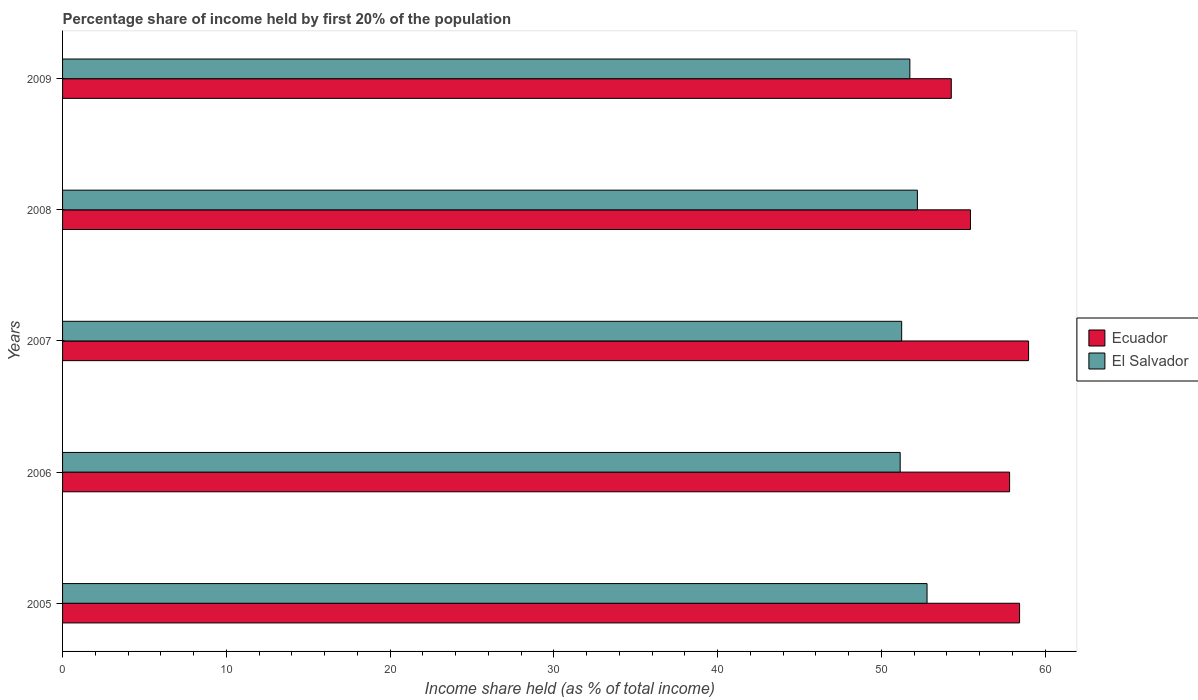How many different coloured bars are there?
Offer a terse response. 2. How many groups of bars are there?
Your response must be concise. 5. Are the number of bars per tick equal to the number of legend labels?
Your answer should be compact. Yes. How many bars are there on the 5th tick from the bottom?
Make the answer very short. 2. In how many cases, is the number of bars for a given year not equal to the number of legend labels?
Your response must be concise. 0. What is the share of income held by first 20% of the population in El Salvador in 2006?
Provide a succinct answer. 51.15. Across all years, what is the maximum share of income held by first 20% of the population in El Salvador?
Make the answer very short. 52.79. Across all years, what is the minimum share of income held by first 20% of the population in Ecuador?
Your answer should be compact. 54.27. In which year was the share of income held by first 20% of the population in Ecuador maximum?
Offer a terse response. 2007. In which year was the share of income held by first 20% of the population in El Salvador minimum?
Your response must be concise. 2006. What is the total share of income held by first 20% of the population in El Salvador in the graph?
Make the answer very short. 259.12. What is the difference between the share of income held by first 20% of the population in Ecuador in 2005 and that in 2006?
Ensure brevity in your answer.  0.61. What is the difference between the share of income held by first 20% of the population in El Salvador in 2005 and the share of income held by first 20% of the population in Ecuador in 2009?
Give a very brief answer. -1.48. What is the average share of income held by first 20% of the population in Ecuador per year?
Keep it short and to the point. 56.99. In the year 2008, what is the difference between the share of income held by first 20% of the population in El Salvador and share of income held by first 20% of the population in Ecuador?
Provide a short and direct response. -3.24. What is the ratio of the share of income held by first 20% of the population in El Salvador in 2005 to that in 2008?
Offer a terse response. 1.01. Is the share of income held by first 20% of the population in Ecuador in 2006 less than that in 2009?
Offer a terse response. No. What is the difference between the highest and the second highest share of income held by first 20% of the population in Ecuador?
Your answer should be very brief. 0.55. What is the difference between the highest and the lowest share of income held by first 20% of the population in Ecuador?
Provide a succinct answer. 4.72. What does the 2nd bar from the top in 2009 represents?
Your answer should be very brief. Ecuador. What does the 2nd bar from the bottom in 2006 represents?
Keep it short and to the point. El Salvador. How many bars are there?
Provide a short and direct response. 10. How many years are there in the graph?
Give a very brief answer. 5. Are the values on the major ticks of X-axis written in scientific E-notation?
Offer a terse response. No. Does the graph contain any zero values?
Offer a terse response. No. Does the graph contain grids?
Give a very brief answer. No. What is the title of the graph?
Provide a succinct answer. Percentage share of income held by first 20% of the population. Does "Russian Federation" appear as one of the legend labels in the graph?
Your answer should be compact. No. What is the label or title of the X-axis?
Provide a succinct answer. Income share held (as % of total income). What is the Income share held (as % of total income) in Ecuador in 2005?
Your answer should be very brief. 58.44. What is the Income share held (as % of total income) of El Salvador in 2005?
Give a very brief answer. 52.79. What is the Income share held (as % of total income) of Ecuador in 2006?
Give a very brief answer. 57.83. What is the Income share held (as % of total income) in El Salvador in 2006?
Make the answer very short. 51.15. What is the Income share held (as % of total income) of Ecuador in 2007?
Make the answer very short. 58.99. What is the Income share held (as % of total income) of El Salvador in 2007?
Your answer should be very brief. 51.24. What is the Income share held (as % of total income) of Ecuador in 2008?
Give a very brief answer. 55.44. What is the Income share held (as % of total income) of El Salvador in 2008?
Ensure brevity in your answer.  52.2. What is the Income share held (as % of total income) of Ecuador in 2009?
Offer a very short reply. 54.27. What is the Income share held (as % of total income) in El Salvador in 2009?
Offer a terse response. 51.74. Across all years, what is the maximum Income share held (as % of total income) of Ecuador?
Provide a short and direct response. 58.99. Across all years, what is the maximum Income share held (as % of total income) in El Salvador?
Your response must be concise. 52.79. Across all years, what is the minimum Income share held (as % of total income) of Ecuador?
Keep it short and to the point. 54.27. Across all years, what is the minimum Income share held (as % of total income) of El Salvador?
Your answer should be very brief. 51.15. What is the total Income share held (as % of total income) in Ecuador in the graph?
Offer a terse response. 284.97. What is the total Income share held (as % of total income) in El Salvador in the graph?
Offer a terse response. 259.12. What is the difference between the Income share held (as % of total income) in Ecuador in 2005 and that in 2006?
Provide a succinct answer. 0.61. What is the difference between the Income share held (as % of total income) of El Salvador in 2005 and that in 2006?
Your answer should be compact. 1.64. What is the difference between the Income share held (as % of total income) in Ecuador in 2005 and that in 2007?
Ensure brevity in your answer.  -0.55. What is the difference between the Income share held (as % of total income) in El Salvador in 2005 and that in 2007?
Make the answer very short. 1.55. What is the difference between the Income share held (as % of total income) in El Salvador in 2005 and that in 2008?
Offer a terse response. 0.59. What is the difference between the Income share held (as % of total income) of Ecuador in 2005 and that in 2009?
Make the answer very short. 4.17. What is the difference between the Income share held (as % of total income) in Ecuador in 2006 and that in 2007?
Your response must be concise. -1.16. What is the difference between the Income share held (as % of total income) of El Salvador in 2006 and that in 2007?
Your answer should be compact. -0.09. What is the difference between the Income share held (as % of total income) of Ecuador in 2006 and that in 2008?
Your answer should be very brief. 2.39. What is the difference between the Income share held (as % of total income) in El Salvador in 2006 and that in 2008?
Provide a succinct answer. -1.05. What is the difference between the Income share held (as % of total income) in Ecuador in 2006 and that in 2009?
Offer a very short reply. 3.56. What is the difference between the Income share held (as % of total income) of El Salvador in 2006 and that in 2009?
Keep it short and to the point. -0.59. What is the difference between the Income share held (as % of total income) of Ecuador in 2007 and that in 2008?
Your answer should be very brief. 3.55. What is the difference between the Income share held (as % of total income) of El Salvador in 2007 and that in 2008?
Provide a short and direct response. -0.96. What is the difference between the Income share held (as % of total income) in Ecuador in 2007 and that in 2009?
Make the answer very short. 4.72. What is the difference between the Income share held (as % of total income) in El Salvador in 2007 and that in 2009?
Keep it short and to the point. -0.5. What is the difference between the Income share held (as % of total income) of Ecuador in 2008 and that in 2009?
Keep it short and to the point. 1.17. What is the difference between the Income share held (as % of total income) of El Salvador in 2008 and that in 2009?
Your answer should be very brief. 0.46. What is the difference between the Income share held (as % of total income) of Ecuador in 2005 and the Income share held (as % of total income) of El Salvador in 2006?
Keep it short and to the point. 7.29. What is the difference between the Income share held (as % of total income) of Ecuador in 2005 and the Income share held (as % of total income) of El Salvador in 2007?
Offer a very short reply. 7.2. What is the difference between the Income share held (as % of total income) in Ecuador in 2005 and the Income share held (as % of total income) in El Salvador in 2008?
Offer a very short reply. 6.24. What is the difference between the Income share held (as % of total income) of Ecuador in 2005 and the Income share held (as % of total income) of El Salvador in 2009?
Ensure brevity in your answer.  6.7. What is the difference between the Income share held (as % of total income) of Ecuador in 2006 and the Income share held (as % of total income) of El Salvador in 2007?
Provide a succinct answer. 6.59. What is the difference between the Income share held (as % of total income) in Ecuador in 2006 and the Income share held (as % of total income) in El Salvador in 2008?
Your answer should be compact. 5.63. What is the difference between the Income share held (as % of total income) of Ecuador in 2006 and the Income share held (as % of total income) of El Salvador in 2009?
Your answer should be very brief. 6.09. What is the difference between the Income share held (as % of total income) in Ecuador in 2007 and the Income share held (as % of total income) in El Salvador in 2008?
Your answer should be very brief. 6.79. What is the difference between the Income share held (as % of total income) in Ecuador in 2007 and the Income share held (as % of total income) in El Salvador in 2009?
Give a very brief answer. 7.25. What is the difference between the Income share held (as % of total income) of Ecuador in 2008 and the Income share held (as % of total income) of El Salvador in 2009?
Your answer should be very brief. 3.7. What is the average Income share held (as % of total income) in Ecuador per year?
Provide a succinct answer. 56.99. What is the average Income share held (as % of total income) in El Salvador per year?
Your answer should be compact. 51.82. In the year 2005, what is the difference between the Income share held (as % of total income) in Ecuador and Income share held (as % of total income) in El Salvador?
Make the answer very short. 5.65. In the year 2006, what is the difference between the Income share held (as % of total income) in Ecuador and Income share held (as % of total income) in El Salvador?
Make the answer very short. 6.68. In the year 2007, what is the difference between the Income share held (as % of total income) in Ecuador and Income share held (as % of total income) in El Salvador?
Provide a succinct answer. 7.75. In the year 2008, what is the difference between the Income share held (as % of total income) of Ecuador and Income share held (as % of total income) of El Salvador?
Make the answer very short. 3.24. In the year 2009, what is the difference between the Income share held (as % of total income) in Ecuador and Income share held (as % of total income) in El Salvador?
Your response must be concise. 2.53. What is the ratio of the Income share held (as % of total income) in Ecuador in 2005 to that in 2006?
Give a very brief answer. 1.01. What is the ratio of the Income share held (as % of total income) of El Salvador in 2005 to that in 2006?
Offer a terse response. 1.03. What is the ratio of the Income share held (as % of total income) in Ecuador in 2005 to that in 2007?
Your answer should be very brief. 0.99. What is the ratio of the Income share held (as % of total income) of El Salvador in 2005 to that in 2007?
Offer a very short reply. 1.03. What is the ratio of the Income share held (as % of total income) in Ecuador in 2005 to that in 2008?
Keep it short and to the point. 1.05. What is the ratio of the Income share held (as % of total income) of El Salvador in 2005 to that in 2008?
Provide a succinct answer. 1.01. What is the ratio of the Income share held (as % of total income) of Ecuador in 2005 to that in 2009?
Your response must be concise. 1.08. What is the ratio of the Income share held (as % of total income) in El Salvador in 2005 to that in 2009?
Give a very brief answer. 1.02. What is the ratio of the Income share held (as % of total income) of Ecuador in 2006 to that in 2007?
Ensure brevity in your answer.  0.98. What is the ratio of the Income share held (as % of total income) of El Salvador in 2006 to that in 2007?
Make the answer very short. 1. What is the ratio of the Income share held (as % of total income) of Ecuador in 2006 to that in 2008?
Offer a terse response. 1.04. What is the ratio of the Income share held (as % of total income) in El Salvador in 2006 to that in 2008?
Your answer should be compact. 0.98. What is the ratio of the Income share held (as % of total income) of Ecuador in 2006 to that in 2009?
Your response must be concise. 1.07. What is the ratio of the Income share held (as % of total income) in El Salvador in 2006 to that in 2009?
Provide a succinct answer. 0.99. What is the ratio of the Income share held (as % of total income) in Ecuador in 2007 to that in 2008?
Make the answer very short. 1.06. What is the ratio of the Income share held (as % of total income) in El Salvador in 2007 to that in 2008?
Your response must be concise. 0.98. What is the ratio of the Income share held (as % of total income) in Ecuador in 2007 to that in 2009?
Your response must be concise. 1.09. What is the ratio of the Income share held (as % of total income) of El Salvador in 2007 to that in 2009?
Your response must be concise. 0.99. What is the ratio of the Income share held (as % of total income) of Ecuador in 2008 to that in 2009?
Make the answer very short. 1.02. What is the ratio of the Income share held (as % of total income) of El Salvador in 2008 to that in 2009?
Offer a terse response. 1.01. What is the difference between the highest and the second highest Income share held (as % of total income) of Ecuador?
Provide a short and direct response. 0.55. What is the difference between the highest and the second highest Income share held (as % of total income) of El Salvador?
Offer a terse response. 0.59. What is the difference between the highest and the lowest Income share held (as % of total income) of Ecuador?
Your answer should be compact. 4.72. What is the difference between the highest and the lowest Income share held (as % of total income) of El Salvador?
Offer a very short reply. 1.64. 